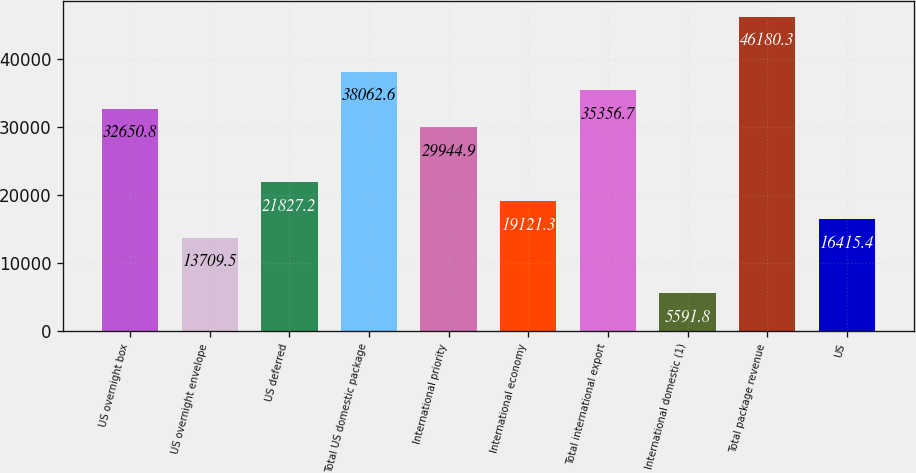Convert chart to OTSL. <chart><loc_0><loc_0><loc_500><loc_500><bar_chart><fcel>US overnight box<fcel>US overnight envelope<fcel>US deferred<fcel>Total US domestic package<fcel>International priority<fcel>International economy<fcel>Total international export<fcel>International domestic (1)<fcel>Total package revenue<fcel>US<nl><fcel>32650.8<fcel>13709.5<fcel>21827.2<fcel>38062.6<fcel>29944.9<fcel>19121.3<fcel>35356.7<fcel>5591.8<fcel>46180.3<fcel>16415.4<nl></chart> 